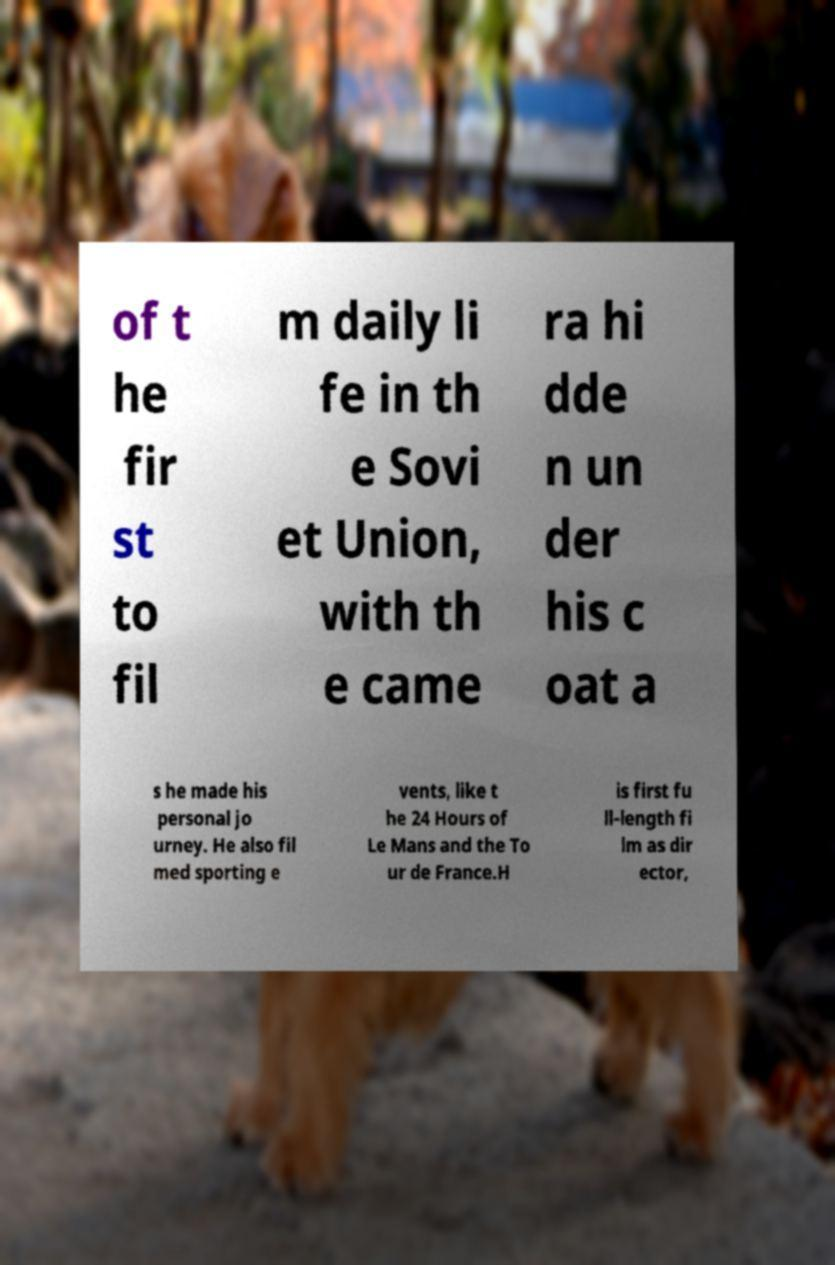There's text embedded in this image that I need extracted. Can you transcribe it verbatim? of t he fir st to fil m daily li fe in th e Sovi et Union, with th e came ra hi dde n un der his c oat a s he made his personal jo urney. He also fil med sporting e vents, like t he 24 Hours of Le Mans and the To ur de France.H is first fu ll-length fi lm as dir ector, 